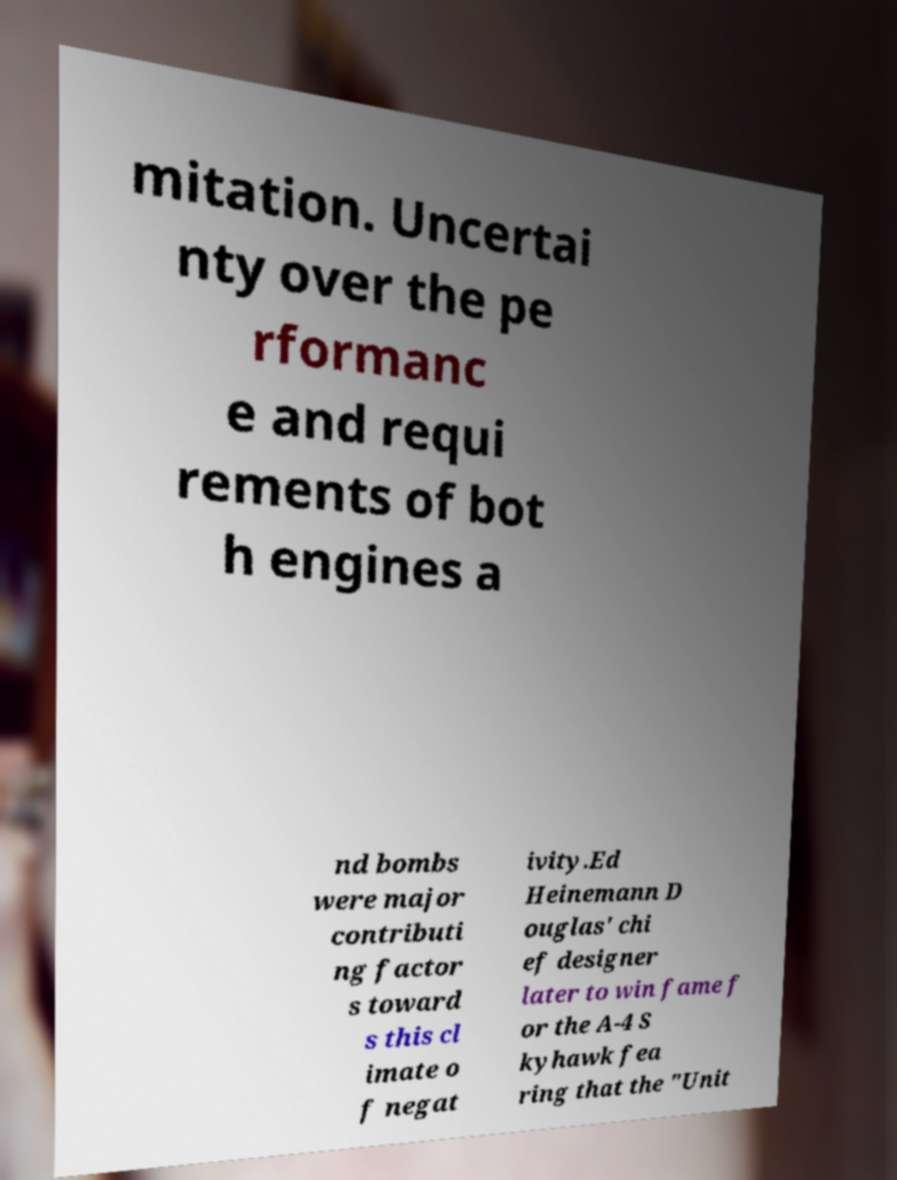Can you read and provide the text displayed in the image?This photo seems to have some interesting text. Can you extract and type it out for me? mitation. Uncertai nty over the pe rformanc e and requi rements of bot h engines a nd bombs were major contributi ng factor s toward s this cl imate o f negat ivity.Ed Heinemann D ouglas' chi ef designer later to win fame f or the A-4 S kyhawk fea ring that the "Unit 